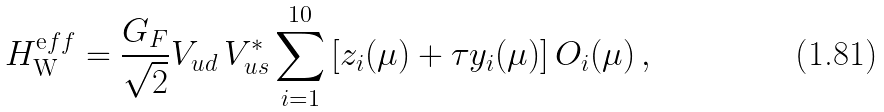Convert formula to latex. <formula><loc_0><loc_0><loc_500><loc_500>H _ { \mathrm W } ^ { \mathrm e f f } = \frac { G _ { F } } { \sqrt { 2 } } V _ { u d } \, V ^ { * } _ { u s } \sum _ { i = 1 } ^ { 1 0 } \left [ z _ { i } ( \mu ) + \tau y _ { i } ( \mu ) \right ] O _ { i } ( \mu ) \, ,</formula> 